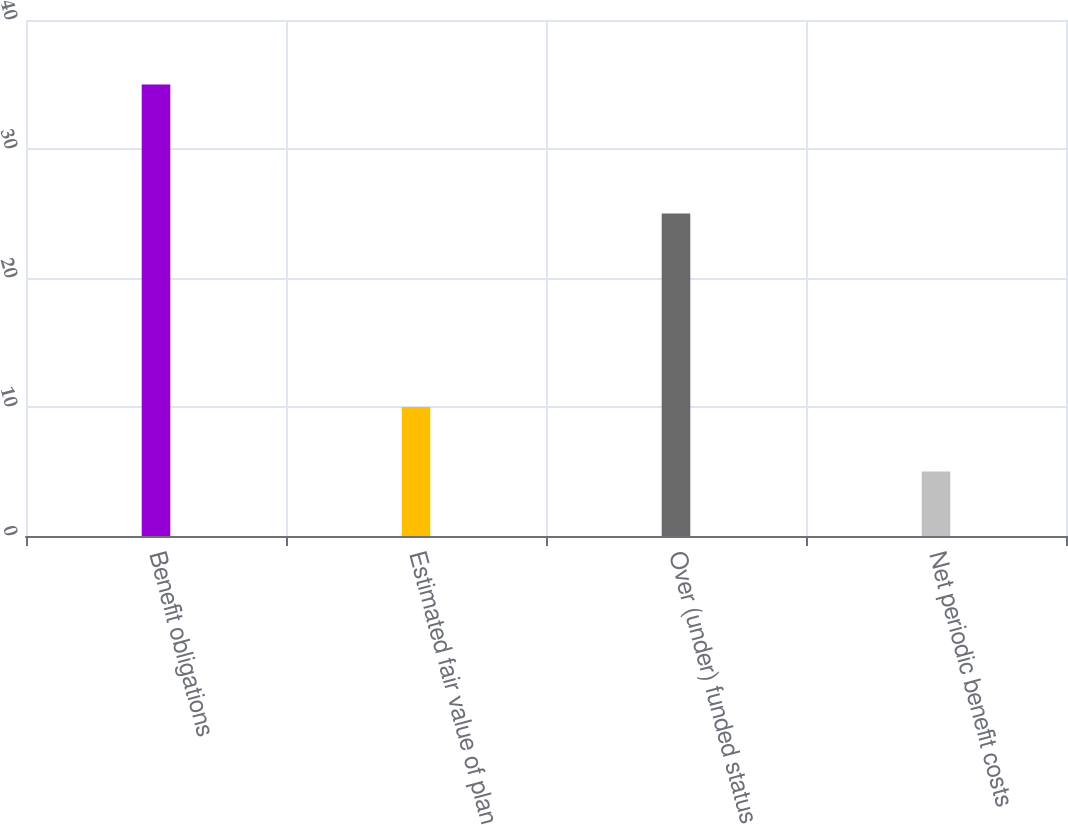Convert chart. <chart><loc_0><loc_0><loc_500><loc_500><bar_chart><fcel>Benefit obligations<fcel>Estimated fair value of plan<fcel>Over (under) funded status<fcel>Net periodic benefit costs<nl><fcel>35<fcel>10<fcel>25<fcel>5<nl></chart> 